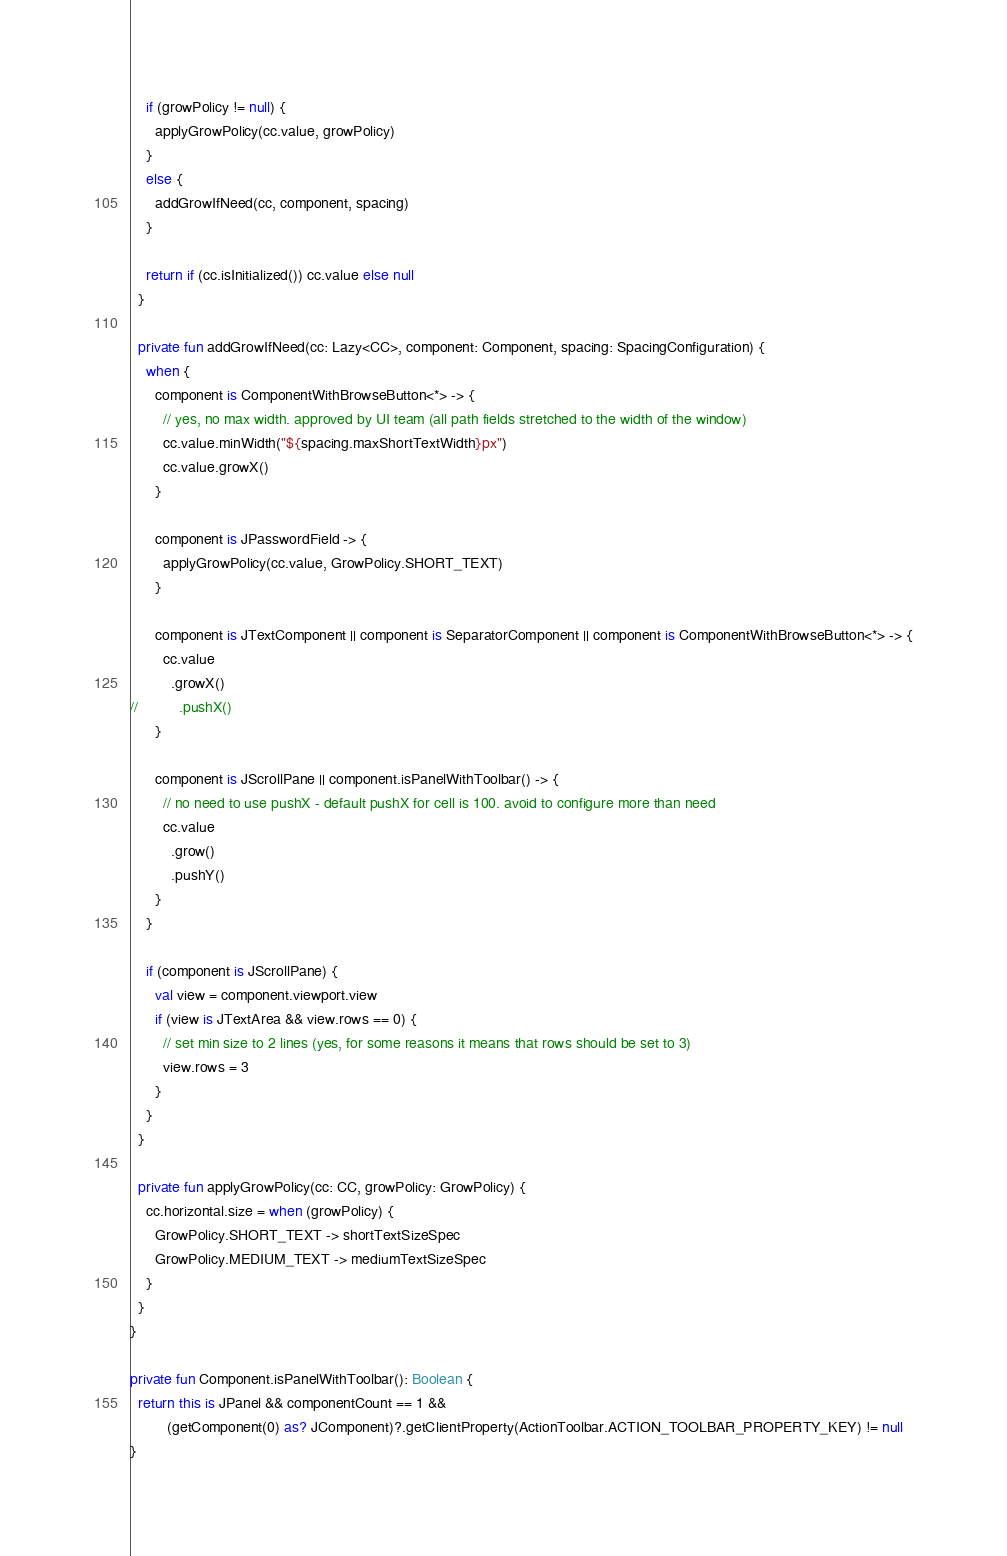Convert code to text. <code><loc_0><loc_0><loc_500><loc_500><_Kotlin_>
    if (growPolicy != null) {
      applyGrowPolicy(cc.value, growPolicy)
    }
    else {
      addGrowIfNeed(cc, component, spacing)
    }

    return if (cc.isInitialized()) cc.value else null
  }

  private fun addGrowIfNeed(cc: Lazy<CC>, component: Component, spacing: SpacingConfiguration) {
    when {
      component is ComponentWithBrowseButton<*> -> {
        // yes, no max width. approved by UI team (all path fields stretched to the width of the window)
        cc.value.minWidth("${spacing.maxShortTextWidth}px")
        cc.value.growX()
      }

      component is JPasswordField -> {
        applyGrowPolicy(cc.value, GrowPolicy.SHORT_TEXT)
      }

      component is JTextComponent || component is SeparatorComponent || component is ComponentWithBrowseButton<*> -> {
        cc.value
          .growX()
//          .pushX()
      }

      component is JScrollPane || component.isPanelWithToolbar() -> {
        // no need to use pushX - default pushX for cell is 100. avoid to configure more than need
        cc.value
          .grow()
          .pushY()
      }
    }

    if (component is JScrollPane) {
      val view = component.viewport.view
      if (view is JTextArea && view.rows == 0) {
        // set min size to 2 lines (yes, for some reasons it means that rows should be set to 3)
        view.rows = 3
      }
    }
  }

  private fun applyGrowPolicy(cc: CC, growPolicy: GrowPolicy) {
    cc.horizontal.size = when (growPolicy) {
      GrowPolicy.SHORT_TEXT -> shortTextSizeSpec
      GrowPolicy.MEDIUM_TEXT -> mediumTextSizeSpec
    }
  }
}

private fun Component.isPanelWithToolbar(): Boolean {
  return this is JPanel && componentCount == 1 &&
         (getComponent(0) as? JComponent)?.getClientProperty(ActionToolbar.ACTION_TOOLBAR_PROPERTY_KEY) != null
}</code> 